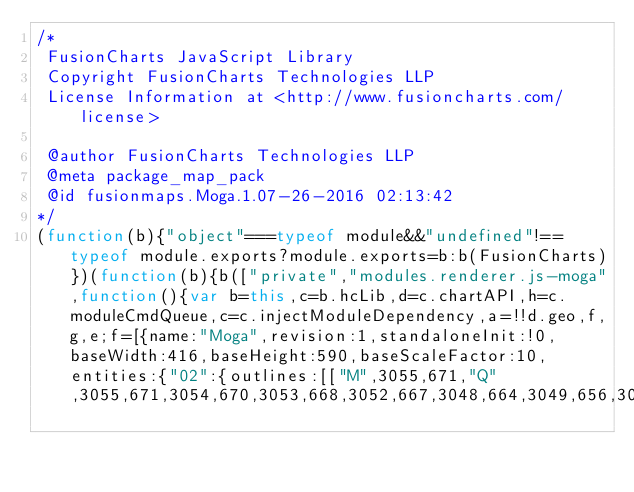Convert code to text. <code><loc_0><loc_0><loc_500><loc_500><_JavaScript_>/*
 FusionCharts JavaScript Library
 Copyright FusionCharts Technologies LLP
 License Information at <http://www.fusioncharts.com/license>

 @author FusionCharts Technologies LLP
 @meta package_map_pack
 @id fusionmaps.Moga.1.07-26-2016 02:13:42
*/
(function(b){"object"===typeof module&&"undefined"!==typeof module.exports?module.exports=b:b(FusionCharts)})(function(b){b(["private","modules.renderer.js-moga",function(){var b=this,c=b.hcLib,d=c.chartAPI,h=c.moduleCmdQueue,c=c.injectModuleDependency,a=!!d.geo,f,g,e;f=[{name:"Moga",revision:1,standaloneInit:!0,baseWidth:416,baseHeight:590,baseScaleFactor:10,entities:{"02":{outlines:[["M",3055,671,"Q",3055,671,3054,670,3053,668,3052,667,3048,664,3049,656,3049,654,3048,652,3042,646,3032,646,3031,</code> 